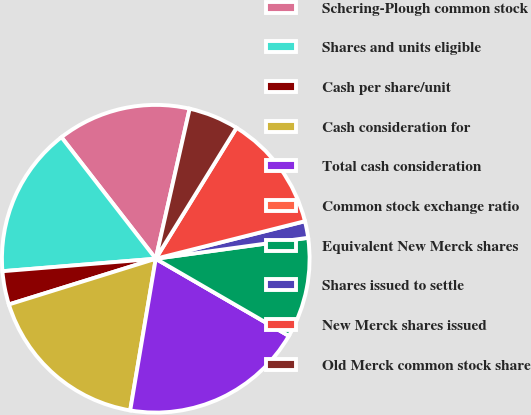<chart> <loc_0><loc_0><loc_500><loc_500><pie_chart><fcel>Schering-Plough common stock<fcel>Shares and units eligible<fcel>Cash per share/unit<fcel>Cash consideration for<fcel>Total cash consideration<fcel>Common stock exchange ratio<fcel>Equivalent New Merck shares<fcel>Shares issued to settle<fcel>New Merck shares issued<fcel>Old Merck common stock share<nl><fcel>14.04%<fcel>15.79%<fcel>3.51%<fcel>17.54%<fcel>19.3%<fcel>0.0%<fcel>10.53%<fcel>1.75%<fcel>12.28%<fcel>5.26%<nl></chart> 